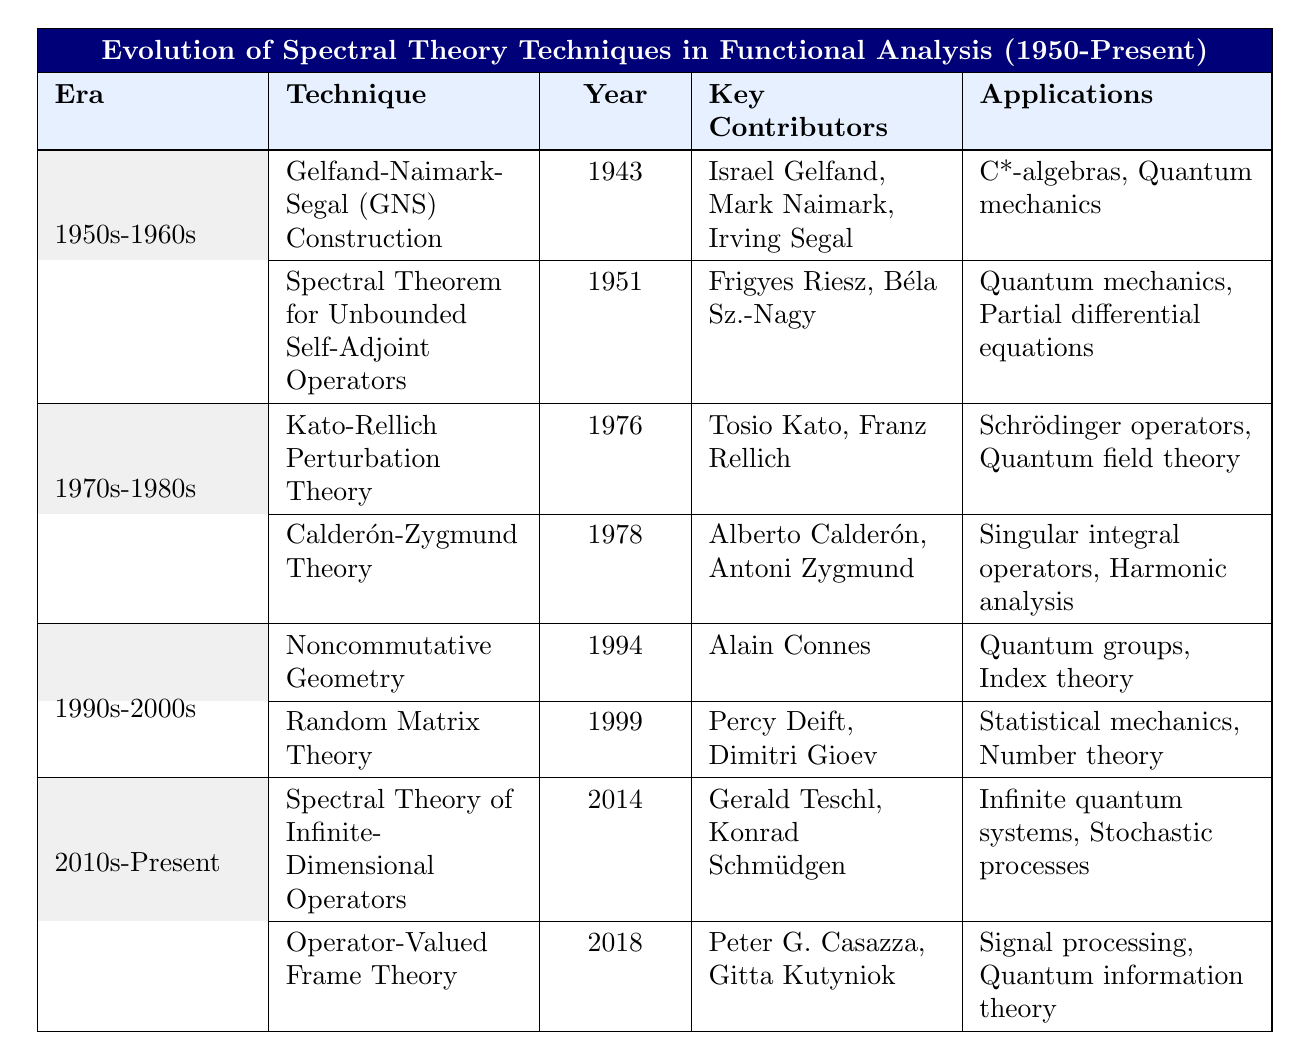What technique was developed first in the evolution of spectral theory? The first technique listed in the table is the Gelfand-Naimark-Segal (GNS) Construction, which was developed in 1943.
Answer: Gelfand-Naimark-Segal (GNS) Construction Which era saw the introduction of Random Matrix Theory? The Random Matrix Theory was introduced in the era of 1990s-2000s, as listed in the table.
Answer: 1990s-2000s Who are the key contributors to Kato-Rellich Perturbation Theory? The table indicates that the key contributors to this technique are Tosio Kato and Franz Rellich.
Answer: Tosio Kato, Franz Rellich What are the applications for Spectral Theorem for Unbounded Self-Adjoint Operators? According to the table, its applications are found in quantum mechanics and partial differential equations.
Answer: Quantum mechanics, partial differential equations How many techniques were developed in the 1970s-1980s? Two techniques are listed for this era: Kato-Rellich Perturbation Theory and Calderón-Zygmund Theory.
Answer: 2 Is Noncommutative Geometry associated with Quantum groups? Yes, the table specifies that Noncommutative Geometry's applications include Quantum groups.
Answer: Yes Which technique was developed last according to the table? The last technique introduced is the Operator-Valued Frame Theory, which was developed in 2018.
Answer: Operator-Valued Frame Theory What is the primary focus of research in the 2010s-Present era? The techniques listed for this era focus on Spectral Theory of Infinite-Dimensional Operators and Operator-Valued Frame Theory.
Answer: Spectral Theory of Infinite-Dimensional Operators, Operator-Valued Frame Theory How does the number of key contributors for the GNS Construction compare to Random Matrix Theory? GNS Construction has three key contributors (Israel Gelfand, Mark Naimark, Irving Segal), while Random Matrix Theory has two (Percy Deift, Dimitri Gioev), indicating more contributors for GNS Construction.
Answer: GNS Construction has more contributors What is one application shared by techniques from different eras? The application of quantum mechanics is shared by the Spectral Theorem for Unbounded Self-Adjoint Operators from the 1950s-1960s and the GNS Construction from 1943; they are both related to quantum mechanics.
Answer: Quantum mechanics 